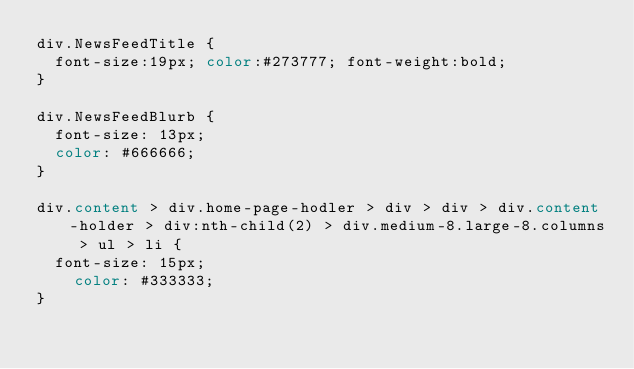<code> <loc_0><loc_0><loc_500><loc_500><_CSS_>div.NewsFeedTitle {
	font-size:19px; color:#273777; font-weight:bold;
}

div.NewsFeedBlurb {
	font-size: 13px;
	color: #666666;
}

div.content > div.home-page-hodler > div > div > div.content-holder > div:nth-child(2) > div.medium-8.large-8.columns > ul > li {
	font-size: 15px;
    color: #333333;
}</code> 